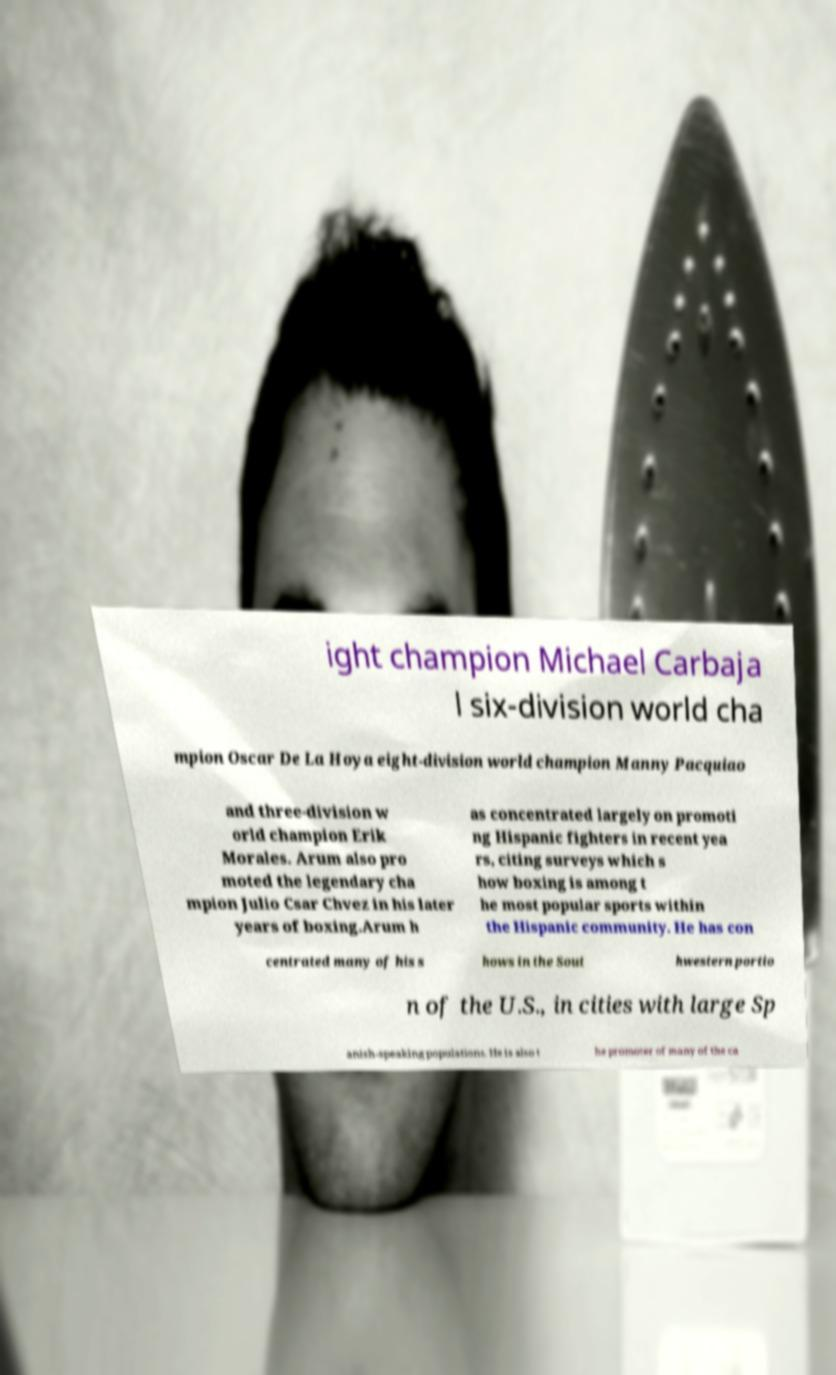For documentation purposes, I need the text within this image transcribed. Could you provide that? ight champion Michael Carbaja l six-division world cha mpion Oscar De La Hoya eight-division world champion Manny Pacquiao and three-division w orld champion Erik Morales. Arum also pro moted the legendary cha mpion Julio Csar Chvez in his later years of boxing.Arum h as concentrated largely on promoti ng Hispanic fighters in recent yea rs, citing surveys which s how boxing is among t he most popular sports within the Hispanic community. He has con centrated many of his s hows in the Sout hwestern portio n of the U.S., in cities with large Sp anish-speaking populations. He is also t he promoter of many of the ca 